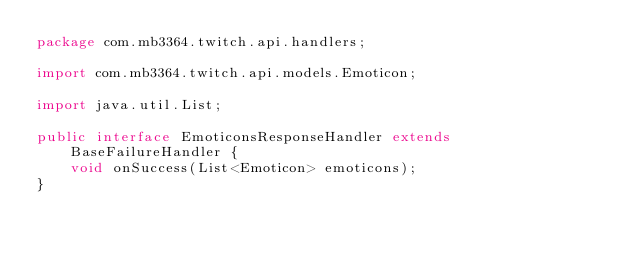Convert code to text. <code><loc_0><loc_0><loc_500><loc_500><_Java_>package com.mb3364.twitch.api.handlers;

import com.mb3364.twitch.api.models.Emoticon;

import java.util.List;

public interface EmoticonsResponseHandler extends BaseFailureHandler {
    void onSuccess(List<Emoticon> emoticons);
}
</code> 